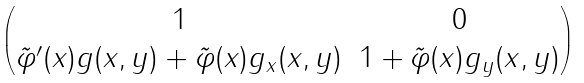<formula> <loc_0><loc_0><loc_500><loc_500>\begin{pmatrix} 1 & 0 \\ \tilde { \varphi } ^ { \prime } ( x ) g ( x , y ) + \tilde { \varphi } ( x ) g _ { x } ( x , y ) & 1 + \tilde { \varphi } ( x ) g _ { y } ( x , y ) \end{pmatrix}</formula> 